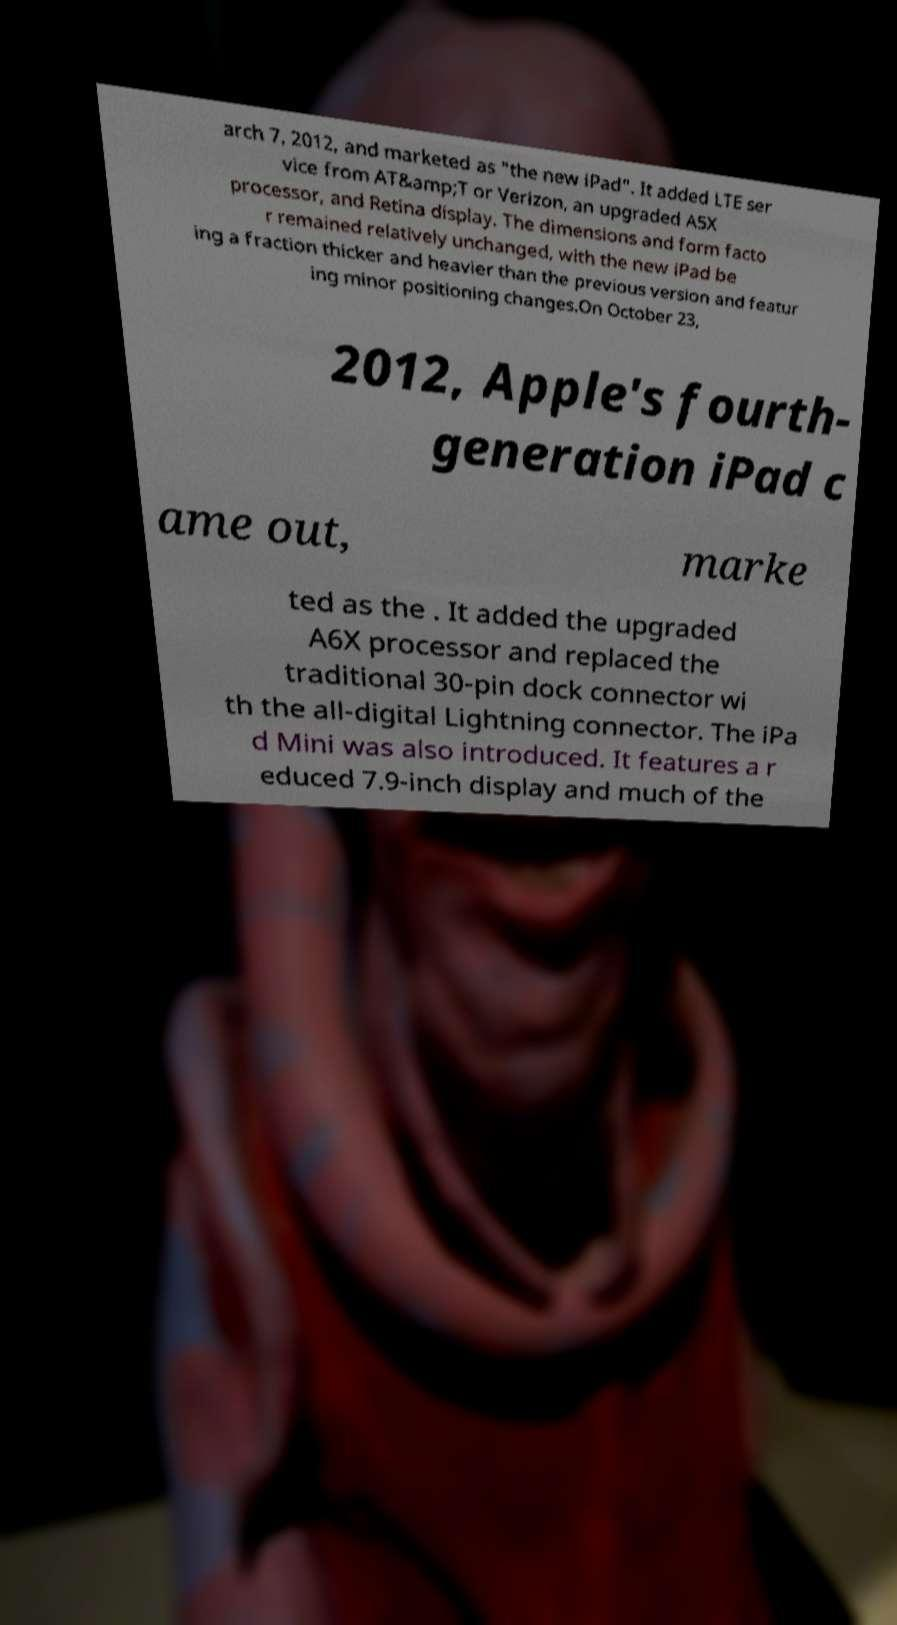Please identify and transcribe the text found in this image. arch 7, 2012, and marketed as "the new iPad". It added LTE ser vice from AT&amp;T or Verizon, an upgraded A5X processor, and Retina display. The dimensions and form facto r remained relatively unchanged, with the new iPad be ing a fraction thicker and heavier than the previous version and featur ing minor positioning changes.On October 23, 2012, Apple's fourth- generation iPad c ame out, marke ted as the . It added the upgraded A6X processor and replaced the traditional 30-pin dock connector wi th the all-digital Lightning connector. The iPa d Mini was also introduced. It features a r educed 7.9-inch display and much of the 